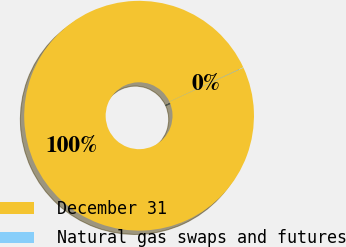Convert chart. <chart><loc_0><loc_0><loc_500><loc_500><pie_chart><fcel>December 31<fcel>Natural gas swaps and futures<nl><fcel>99.95%<fcel>0.05%<nl></chart> 